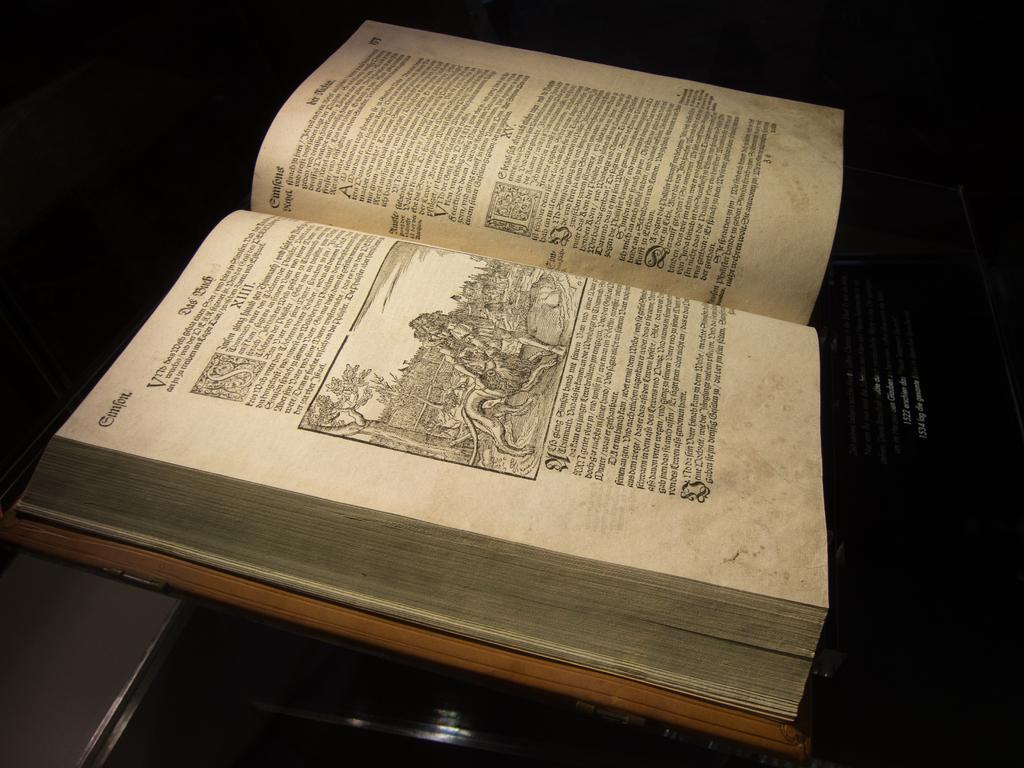What piece of furniture is present in the image? There is a desk in the image. What object is placed on the desk? There is a book on the desk. Is the book opened or closed? The book is opened. What can be found inside the book? There is information and an image in the book. What type of surprise can be seen on the earth in the image? There is no earth or surprise present in the image; it features a desk with a book on it. 